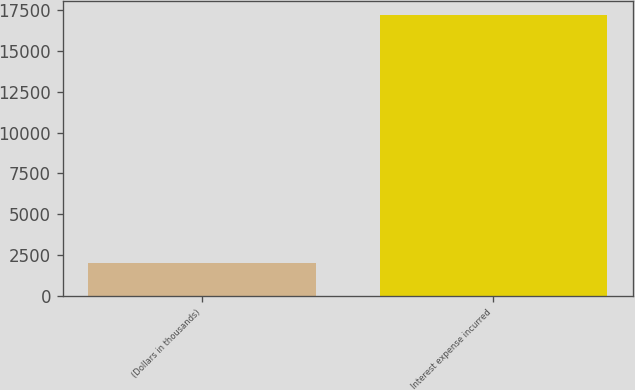Convert chart. <chart><loc_0><loc_0><loc_500><loc_500><bar_chart><fcel>(Dollars in thousands)<fcel>Interest expense incurred<nl><fcel>2010<fcel>17219<nl></chart> 